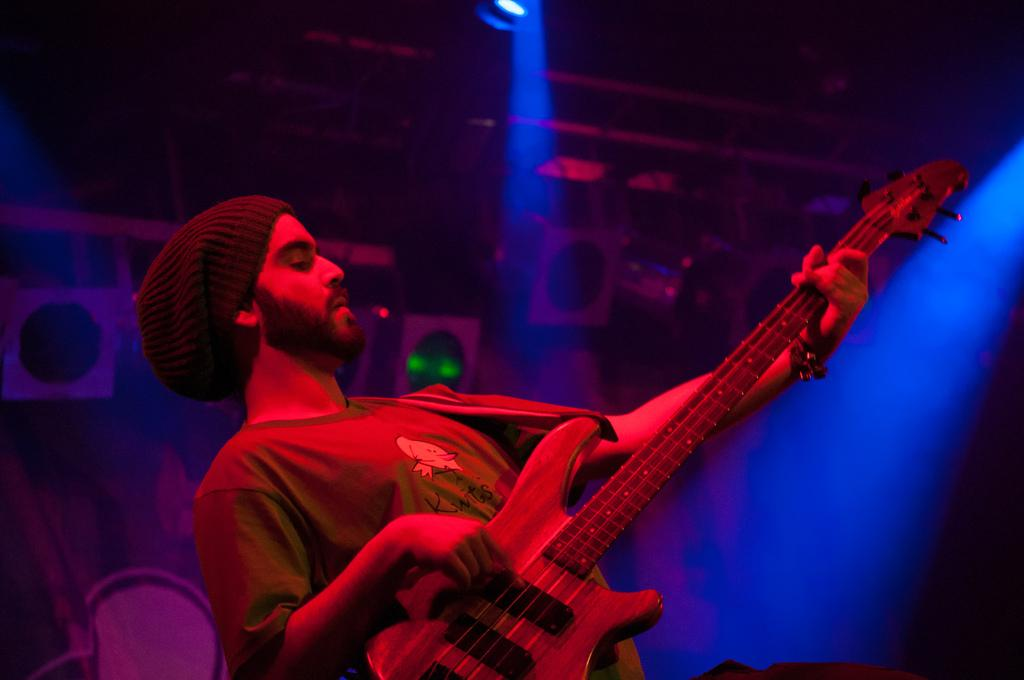What is the main subject of the image? The main subject of the image is a person. What is the person doing in the image? The person is playing the guitar. Can you describe the background of the image? The background of the image is dark. How many boys are visible in the image? There is no mention of boys in the image, as the main subject is a person playing the guitar. What is the age of the baby in the image? There is no baby present in the image; it features a person playing the guitar against a dark background. 